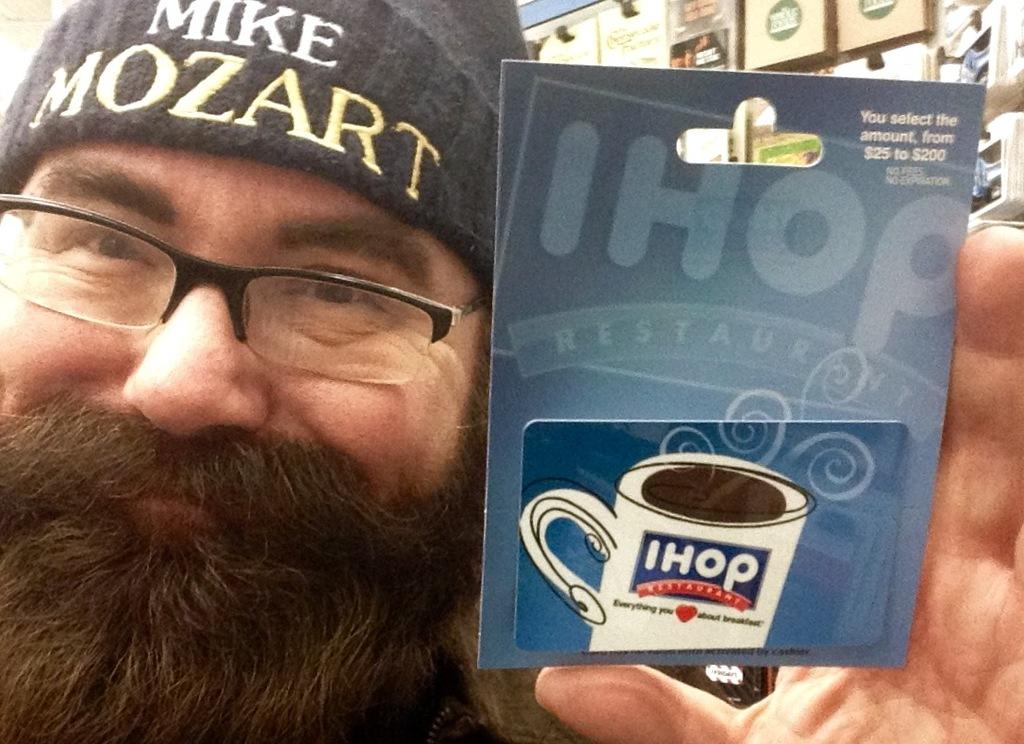What is the main subject in the center of the image? There is a person in the center of the image. What is the person holding in the image? The person is holding a paper. Can you describe the background of the image? There are objects visible in the background of the image. What type of bun is the person eating in the image? There is no bun present in the image; the person is holding a paper. What story is the person telling in the image? There is no indication in the image that the person is telling a story. 